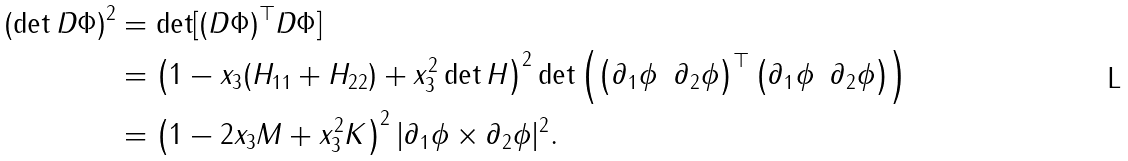<formula> <loc_0><loc_0><loc_500><loc_500>( \det D \Phi ) ^ { 2 } & = \det [ ( D \Phi ) ^ { \top } D \Phi ] \\ & = \left ( 1 - x _ { 3 } ( H _ { 1 1 } + H _ { 2 2 } ) + x _ { 3 } ^ { 2 } \det H \right ) ^ { 2 } \det \left ( \begin{pmatrix} \partial _ { 1 } \phi & \partial _ { 2 } \phi \end{pmatrix} ^ { \top } \begin{pmatrix} \partial _ { 1 } \phi & \partial _ { 2 } \phi \end{pmatrix} \right ) \\ & = \left ( 1 - 2 x _ { 3 } M + x _ { 3 } ^ { 2 } K \right ) ^ { 2 } | \partial _ { 1 } \phi \times \partial _ { 2 } \phi | ^ { 2 } .</formula> 